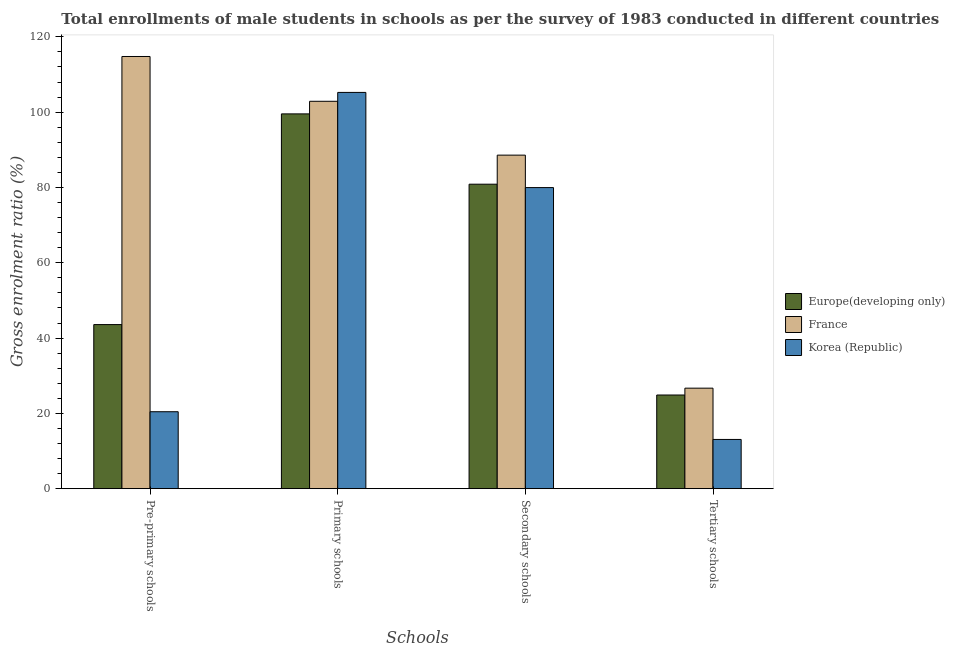How many groups of bars are there?
Keep it short and to the point. 4. Are the number of bars per tick equal to the number of legend labels?
Give a very brief answer. Yes. Are the number of bars on each tick of the X-axis equal?
Make the answer very short. Yes. How many bars are there on the 3rd tick from the right?
Give a very brief answer. 3. What is the label of the 4th group of bars from the left?
Ensure brevity in your answer.  Tertiary schools. What is the gross enrolment ratio(male) in pre-primary schools in Korea (Republic)?
Provide a short and direct response. 20.44. Across all countries, what is the maximum gross enrolment ratio(male) in pre-primary schools?
Provide a succinct answer. 114.79. Across all countries, what is the minimum gross enrolment ratio(male) in primary schools?
Ensure brevity in your answer.  99.54. In which country was the gross enrolment ratio(male) in secondary schools maximum?
Provide a succinct answer. France. In which country was the gross enrolment ratio(male) in tertiary schools minimum?
Your answer should be compact. Korea (Republic). What is the total gross enrolment ratio(male) in tertiary schools in the graph?
Your answer should be compact. 64.65. What is the difference between the gross enrolment ratio(male) in secondary schools in France and that in Korea (Republic)?
Give a very brief answer. 8.62. What is the difference between the gross enrolment ratio(male) in secondary schools in Korea (Republic) and the gross enrolment ratio(male) in primary schools in France?
Your answer should be very brief. -22.92. What is the average gross enrolment ratio(male) in tertiary schools per country?
Make the answer very short. 21.55. What is the difference between the gross enrolment ratio(male) in primary schools and gross enrolment ratio(male) in pre-primary schools in Korea (Republic)?
Your response must be concise. 84.81. In how many countries, is the gross enrolment ratio(male) in secondary schools greater than 24 %?
Provide a short and direct response. 3. What is the ratio of the gross enrolment ratio(male) in tertiary schools in Korea (Republic) to that in France?
Make the answer very short. 0.49. What is the difference between the highest and the second highest gross enrolment ratio(male) in tertiary schools?
Your response must be concise. 1.82. What is the difference between the highest and the lowest gross enrolment ratio(male) in primary schools?
Your response must be concise. 5.7. In how many countries, is the gross enrolment ratio(male) in pre-primary schools greater than the average gross enrolment ratio(male) in pre-primary schools taken over all countries?
Your response must be concise. 1. Is the sum of the gross enrolment ratio(male) in tertiary schools in Korea (Republic) and France greater than the maximum gross enrolment ratio(male) in primary schools across all countries?
Provide a short and direct response. No. What does the 3rd bar from the left in Tertiary schools represents?
Ensure brevity in your answer.  Korea (Republic). How many bars are there?
Make the answer very short. 12. What is the difference between two consecutive major ticks on the Y-axis?
Ensure brevity in your answer.  20. Does the graph contain grids?
Make the answer very short. No. How many legend labels are there?
Your answer should be very brief. 3. What is the title of the graph?
Your answer should be compact. Total enrollments of male students in schools as per the survey of 1983 conducted in different countries. Does "Moldova" appear as one of the legend labels in the graph?
Ensure brevity in your answer.  No. What is the label or title of the X-axis?
Provide a succinct answer. Schools. What is the label or title of the Y-axis?
Your answer should be compact. Gross enrolment ratio (%). What is the Gross enrolment ratio (%) of Europe(developing only) in Pre-primary schools?
Provide a succinct answer. 43.58. What is the Gross enrolment ratio (%) of France in Pre-primary schools?
Your answer should be very brief. 114.79. What is the Gross enrolment ratio (%) of Korea (Republic) in Pre-primary schools?
Your response must be concise. 20.44. What is the Gross enrolment ratio (%) of Europe(developing only) in Primary schools?
Offer a terse response. 99.54. What is the Gross enrolment ratio (%) in France in Primary schools?
Ensure brevity in your answer.  102.89. What is the Gross enrolment ratio (%) in Korea (Republic) in Primary schools?
Your answer should be very brief. 105.25. What is the Gross enrolment ratio (%) of Europe(developing only) in Secondary schools?
Make the answer very short. 80.87. What is the Gross enrolment ratio (%) of France in Secondary schools?
Offer a terse response. 88.59. What is the Gross enrolment ratio (%) in Korea (Republic) in Secondary schools?
Your response must be concise. 79.97. What is the Gross enrolment ratio (%) in Europe(developing only) in Tertiary schools?
Give a very brief answer. 24.88. What is the Gross enrolment ratio (%) of France in Tertiary schools?
Your answer should be compact. 26.7. What is the Gross enrolment ratio (%) of Korea (Republic) in Tertiary schools?
Make the answer very short. 13.08. Across all Schools, what is the maximum Gross enrolment ratio (%) of Europe(developing only)?
Provide a short and direct response. 99.54. Across all Schools, what is the maximum Gross enrolment ratio (%) in France?
Offer a very short reply. 114.79. Across all Schools, what is the maximum Gross enrolment ratio (%) of Korea (Republic)?
Your response must be concise. 105.25. Across all Schools, what is the minimum Gross enrolment ratio (%) in Europe(developing only)?
Your response must be concise. 24.88. Across all Schools, what is the minimum Gross enrolment ratio (%) of France?
Keep it short and to the point. 26.7. Across all Schools, what is the minimum Gross enrolment ratio (%) of Korea (Republic)?
Provide a short and direct response. 13.08. What is the total Gross enrolment ratio (%) in Europe(developing only) in the graph?
Your answer should be very brief. 248.87. What is the total Gross enrolment ratio (%) of France in the graph?
Offer a terse response. 332.96. What is the total Gross enrolment ratio (%) of Korea (Republic) in the graph?
Give a very brief answer. 218.73. What is the difference between the Gross enrolment ratio (%) of Europe(developing only) in Pre-primary schools and that in Primary schools?
Provide a short and direct response. -55.96. What is the difference between the Gross enrolment ratio (%) in France in Pre-primary schools and that in Primary schools?
Ensure brevity in your answer.  11.9. What is the difference between the Gross enrolment ratio (%) of Korea (Republic) in Pre-primary schools and that in Primary schools?
Give a very brief answer. -84.81. What is the difference between the Gross enrolment ratio (%) in Europe(developing only) in Pre-primary schools and that in Secondary schools?
Your response must be concise. -37.29. What is the difference between the Gross enrolment ratio (%) of France in Pre-primary schools and that in Secondary schools?
Your answer should be compact. 26.2. What is the difference between the Gross enrolment ratio (%) of Korea (Republic) in Pre-primary schools and that in Secondary schools?
Your response must be concise. -59.53. What is the difference between the Gross enrolment ratio (%) in Europe(developing only) in Pre-primary schools and that in Tertiary schools?
Your response must be concise. 18.71. What is the difference between the Gross enrolment ratio (%) in France in Pre-primary schools and that in Tertiary schools?
Your answer should be very brief. 88.09. What is the difference between the Gross enrolment ratio (%) in Korea (Republic) in Pre-primary schools and that in Tertiary schools?
Give a very brief answer. 7.36. What is the difference between the Gross enrolment ratio (%) of Europe(developing only) in Primary schools and that in Secondary schools?
Your answer should be very brief. 18.68. What is the difference between the Gross enrolment ratio (%) in France in Primary schools and that in Secondary schools?
Keep it short and to the point. 14.3. What is the difference between the Gross enrolment ratio (%) in Korea (Republic) in Primary schools and that in Secondary schools?
Your answer should be compact. 25.28. What is the difference between the Gross enrolment ratio (%) of Europe(developing only) in Primary schools and that in Tertiary schools?
Your answer should be compact. 74.67. What is the difference between the Gross enrolment ratio (%) of France in Primary schools and that in Tertiary schools?
Give a very brief answer. 76.2. What is the difference between the Gross enrolment ratio (%) in Korea (Republic) in Primary schools and that in Tertiary schools?
Provide a short and direct response. 92.17. What is the difference between the Gross enrolment ratio (%) in Europe(developing only) in Secondary schools and that in Tertiary schools?
Make the answer very short. 55.99. What is the difference between the Gross enrolment ratio (%) in France in Secondary schools and that in Tertiary schools?
Provide a short and direct response. 61.89. What is the difference between the Gross enrolment ratio (%) in Korea (Republic) in Secondary schools and that in Tertiary schools?
Keep it short and to the point. 66.89. What is the difference between the Gross enrolment ratio (%) of Europe(developing only) in Pre-primary schools and the Gross enrolment ratio (%) of France in Primary schools?
Give a very brief answer. -59.31. What is the difference between the Gross enrolment ratio (%) of Europe(developing only) in Pre-primary schools and the Gross enrolment ratio (%) of Korea (Republic) in Primary schools?
Your answer should be compact. -61.66. What is the difference between the Gross enrolment ratio (%) in France in Pre-primary schools and the Gross enrolment ratio (%) in Korea (Republic) in Primary schools?
Ensure brevity in your answer.  9.54. What is the difference between the Gross enrolment ratio (%) of Europe(developing only) in Pre-primary schools and the Gross enrolment ratio (%) of France in Secondary schools?
Your answer should be compact. -45.01. What is the difference between the Gross enrolment ratio (%) of Europe(developing only) in Pre-primary schools and the Gross enrolment ratio (%) of Korea (Republic) in Secondary schools?
Your answer should be compact. -36.39. What is the difference between the Gross enrolment ratio (%) in France in Pre-primary schools and the Gross enrolment ratio (%) in Korea (Republic) in Secondary schools?
Provide a succinct answer. 34.82. What is the difference between the Gross enrolment ratio (%) of Europe(developing only) in Pre-primary schools and the Gross enrolment ratio (%) of France in Tertiary schools?
Your answer should be compact. 16.89. What is the difference between the Gross enrolment ratio (%) in Europe(developing only) in Pre-primary schools and the Gross enrolment ratio (%) in Korea (Republic) in Tertiary schools?
Provide a short and direct response. 30.51. What is the difference between the Gross enrolment ratio (%) of France in Pre-primary schools and the Gross enrolment ratio (%) of Korea (Republic) in Tertiary schools?
Provide a short and direct response. 101.71. What is the difference between the Gross enrolment ratio (%) in Europe(developing only) in Primary schools and the Gross enrolment ratio (%) in France in Secondary schools?
Your response must be concise. 10.95. What is the difference between the Gross enrolment ratio (%) of Europe(developing only) in Primary schools and the Gross enrolment ratio (%) of Korea (Republic) in Secondary schools?
Offer a terse response. 19.58. What is the difference between the Gross enrolment ratio (%) in France in Primary schools and the Gross enrolment ratio (%) in Korea (Republic) in Secondary schools?
Offer a very short reply. 22.92. What is the difference between the Gross enrolment ratio (%) of Europe(developing only) in Primary schools and the Gross enrolment ratio (%) of France in Tertiary schools?
Offer a very short reply. 72.85. What is the difference between the Gross enrolment ratio (%) in Europe(developing only) in Primary schools and the Gross enrolment ratio (%) in Korea (Republic) in Tertiary schools?
Give a very brief answer. 86.47. What is the difference between the Gross enrolment ratio (%) in France in Primary schools and the Gross enrolment ratio (%) in Korea (Republic) in Tertiary schools?
Provide a short and direct response. 89.81. What is the difference between the Gross enrolment ratio (%) of Europe(developing only) in Secondary schools and the Gross enrolment ratio (%) of France in Tertiary schools?
Your response must be concise. 54.17. What is the difference between the Gross enrolment ratio (%) in Europe(developing only) in Secondary schools and the Gross enrolment ratio (%) in Korea (Republic) in Tertiary schools?
Offer a very short reply. 67.79. What is the difference between the Gross enrolment ratio (%) of France in Secondary schools and the Gross enrolment ratio (%) of Korea (Republic) in Tertiary schools?
Provide a succinct answer. 75.51. What is the average Gross enrolment ratio (%) of Europe(developing only) per Schools?
Give a very brief answer. 62.22. What is the average Gross enrolment ratio (%) in France per Schools?
Ensure brevity in your answer.  83.24. What is the average Gross enrolment ratio (%) in Korea (Republic) per Schools?
Give a very brief answer. 54.68. What is the difference between the Gross enrolment ratio (%) of Europe(developing only) and Gross enrolment ratio (%) of France in Pre-primary schools?
Provide a short and direct response. -71.21. What is the difference between the Gross enrolment ratio (%) in Europe(developing only) and Gross enrolment ratio (%) in Korea (Republic) in Pre-primary schools?
Give a very brief answer. 23.14. What is the difference between the Gross enrolment ratio (%) in France and Gross enrolment ratio (%) in Korea (Republic) in Pre-primary schools?
Your answer should be very brief. 94.35. What is the difference between the Gross enrolment ratio (%) of Europe(developing only) and Gross enrolment ratio (%) of France in Primary schools?
Your response must be concise. -3.35. What is the difference between the Gross enrolment ratio (%) of Europe(developing only) and Gross enrolment ratio (%) of Korea (Republic) in Primary schools?
Offer a very short reply. -5.7. What is the difference between the Gross enrolment ratio (%) in France and Gross enrolment ratio (%) in Korea (Republic) in Primary schools?
Your answer should be very brief. -2.36. What is the difference between the Gross enrolment ratio (%) in Europe(developing only) and Gross enrolment ratio (%) in France in Secondary schools?
Provide a succinct answer. -7.72. What is the difference between the Gross enrolment ratio (%) of Europe(developing only) and Gross enrolment ratio (%) of Korea (Republic) in Secondary schools?
Offer a terse response. 0.9. What is the difference between the Gross enrolment ratio (%) in France and Gross enrolment ratio (%) in Korea (Republic) in Secondary schools?
Provide a short and direct response. 8.62. What is the difference between the Gross enrolment ratio (%) of Europe(developing only) and Gross enrolment ratio (%) of France in Tertiary schools?
Give a very brief answer. -1.82. What is the difference between the Gross enrolment ratio (%) of Europe(developing only) and Gross enrolment ratio (%) of Korea (Republic) in Tertiary schools?
Offer a terse response. 11.8. What is the difference between the Gross enrolment ratio (%) of France and Gross enrolment ratio (%) of Korea (Republic) in Tertiary schools?
Offer a very short reply. 13.62. What is the ratio of the Gross enrolment ratio (%) in Europe(developing only) in Pre-primary schools to that in Primary schools?
Give a very brief answer. 0.44. What is the ratio of the Gross enrolment ratio (%) of France in Pre-primary schools to that in Primary schools?
Give a very brief answer. 1.12. What is the ratio of the Gross enrolment ratio (%) of Korea (Republic) in Pre-primary schools to that in Primary schools?
Offer a very short reply. 0.19. What is the ratio of the Gross enrolment ratio (%) in Europe(developing only) in Pre-primary schools to that in Secondary schools?
Provide a succinct answer. 0.54. What is the ratio of the Gross enrolment ratio (%) of France in Pre-primary schools to that in Secondary schools?
Provide a succinct answer. 1.3. What is the ratio of the Gross enrolment ratio (%) in Korea (Republic) in Pre-primary schools to that in Secondary schools?
Your answer should be compact. 0.26. What is the ratio of the Gross enrolment ratio (%) of Europe(developing only) in Pre-primary schools to that in Tertiary schools?
Offer a very short reply. 1.75. What is the ratio of the Gross enrolment ratio (%) of Korea (Republic) in Pre-primary schools to that in Tertiary schools?
Provide a short and direct response. 1.56. What is the ratio of the Gross enrolment ratio (%) in Europe(developing only) in Primary schools to that in Secondary schools?
Your response must be concise. 1.23. What is the ratio of the Gross enrolment ratio (%) of France in Primary schools to that in Secondary schools?
Provide a succinct answer. 1.16. What is the ratio of the Gross enrolment ratio (%) in Korea (Republic) in Primary schools to that in Secondary schools?
Keep it short and to the point. 1.32. What is the ratio of the Gross enrolment ratio (%) of Europe(developing only) in Primary schools to that in Tertiary schools?
Offer a very short reply. 4. What is the ratio of the Gross enrolment ratio (%) of France in Primary schools to that in Tertiary schools?
Provide a short and direct response. 3.85. What is the ratio of the Gross enrolment ratio (%) in Korea (Republic) in Primary schools to that in Tertiary schools?
Keep it short and to the point. 8.05. What is the ratio of the Gross enrolment ratio (%) of Europe(developing only) in Secondary schools to that in Tertiary schools?
Ensure brevity in your answer.  3.25. What is the ratio of the Gross enrolment ratio (%) in France in Secondary schools to that in Tertiary schools?
Ensure brevity in your answer.  3.32. What is the ratio of the Gross enrolment ratio (%) in Korea (Republic) in Secondary schools to that in Tertiary schools?
Ensure brevity in your answer.  6.12. What is the difference between the highest and the second highest Gross enrolment ratio (%) in Europe(developing only)?
Provide a succinct answer. 18.68. What is the difference between the highest and the second highest Gross enrolment ratio (%) in France?
Provide a succinct answer. 11.9. What is the difference between the highest and the second highest Gross enrolment ratio (%) in Korea (Republic)?
Keep it short and to the point. 25.28. What is the difference between the highest and the lowest Gross enrolment ratio (%) of Europe(developing only)?
Your answer should be compact. 74.67. What is the difference between the highest and the lowest Gross enrolment ratio (%) in France?
Provide a succinct answer. 88.09. What is the difference between the highest and the lowest Gross enrolment ratio (%) of Korea (Republic)?
Keep it short and to the point. 92.17. 